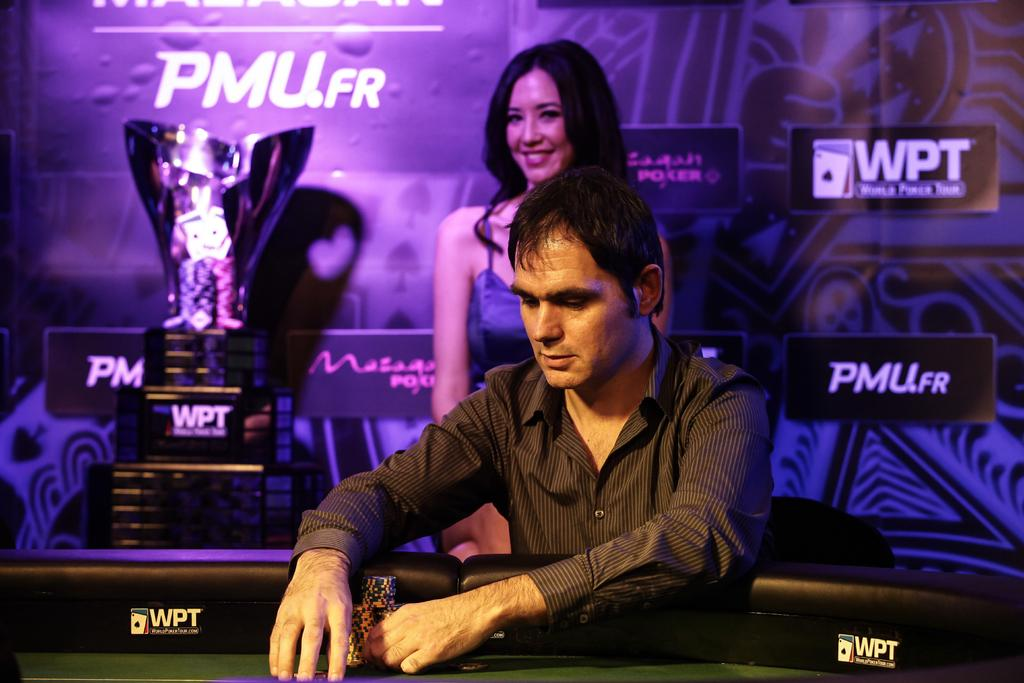Provide a one-sentence caption for the provided image. a man looking down with a female behind him smiling, the advertisements in the back say PMU.FR and WPT. 